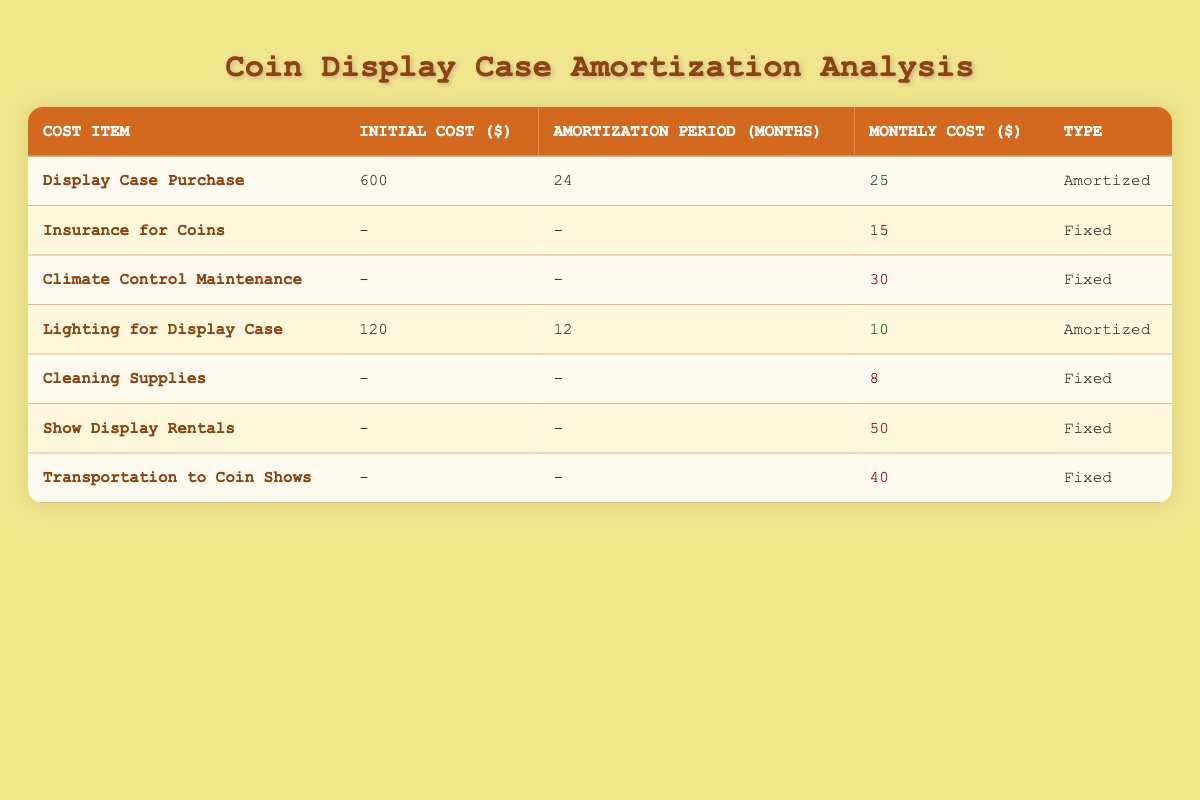What is the monthly cost of Climate Control Maintenance? The table lists the monthly cost of Climate Control Maintenance, which is explicitly stated under the "Monthly Cost ($)" column. It shows a monthly cost of 30.
Answer: 30 What are the initial costs associated with the Display Case Purchase? The initial cost for the Display Case Purchase is shown directly in the "Initial Cost ($)" column, which indicates it is 600.
Answer: 600 How much will you pay monthly in total for the fixed costs? To calculate the total monthly fixed costs, we sum the monthly costs of each fixed item: Insurance for Coins (15) + Climate Control Maintenance (30) + Cleaning Supplies (8) + Show Display Rentals (50) + Transportation to Coin Shows (40). This equals 143.
Answer: 143 Is the Lighting for Display Case considered an amortized cost? The table classifies costs under "Type," and Lighting for Display Case is listed as "Amortized," which confirms it qualifies as an amortized cost.
Answer: Yes What is the total amortized cost per month from the Display Case Purchase and Lighting for Display Case combined? The monthly amortized cost for the Display Case Purchase is 25, and for Lighting for Display Case, it is 10. Adding these together (25 + 10) results in a total of 35.
Answer: 35 Which cost item has the highest monthly cost? By examining the "Monthly Cost ($)" column for all cost items, Show Display Rentals has the highest monthly cost, which is 50.
Answer: Show Display Rentals What is the average monthly cost of the displayed items? To find the average monthly cost, total all monthly costs (25, 15, 30, 10, 8, 50, 40 = 178) and divide by the number of items (7). This gives an average of approximately 25.43.
Answer: 25.43 Are there any costs with an initial cost specified in the table? The table mentions initial costs for the Display Case Purchase and Lighting for Display Case, confirming that there are costs with specified initial values.
Answer: Yes What is the total of the amortization periods for the included cost items? The total of the amortization periods is 24 months for the Display Case Purchase and 12 months for the Lighting for Display Case, resulting in a total of 36 months.
Answer: 36 